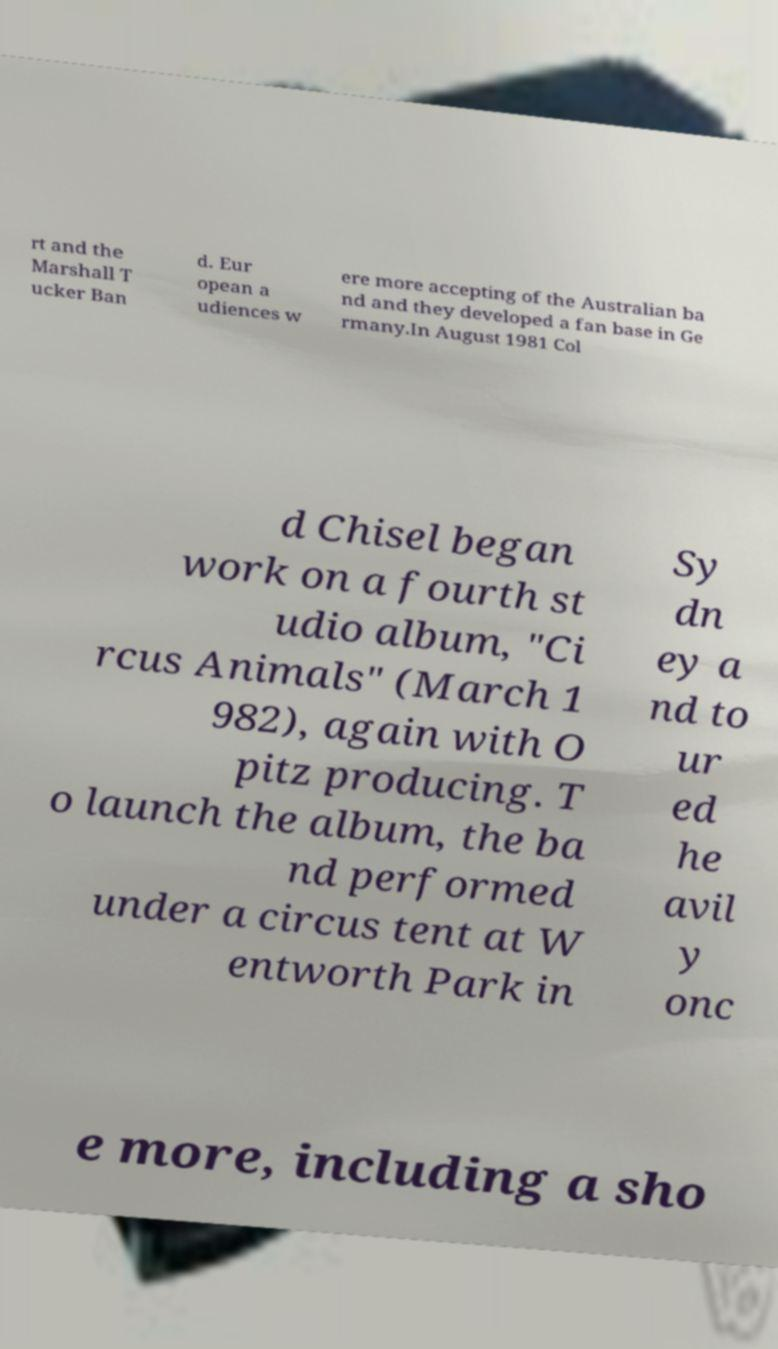I need the written content from this picture converted into text. Can you do that? rt and the Marshall T ucker Ban d. Eur opean a udiences w ere more accepting of the Australian ba nd and they developed a fan base in Ge rmany.In August 1981 Col d Chisel began work on a fourth st udio album, "Ci rcus Animals" (March 1 982), again with O pitz producing. T o launch the album, the ba nd performed under a circus tent at W entworth Park in Sy dn ey a nd to ur ed he avil y onc e more, including a sho 